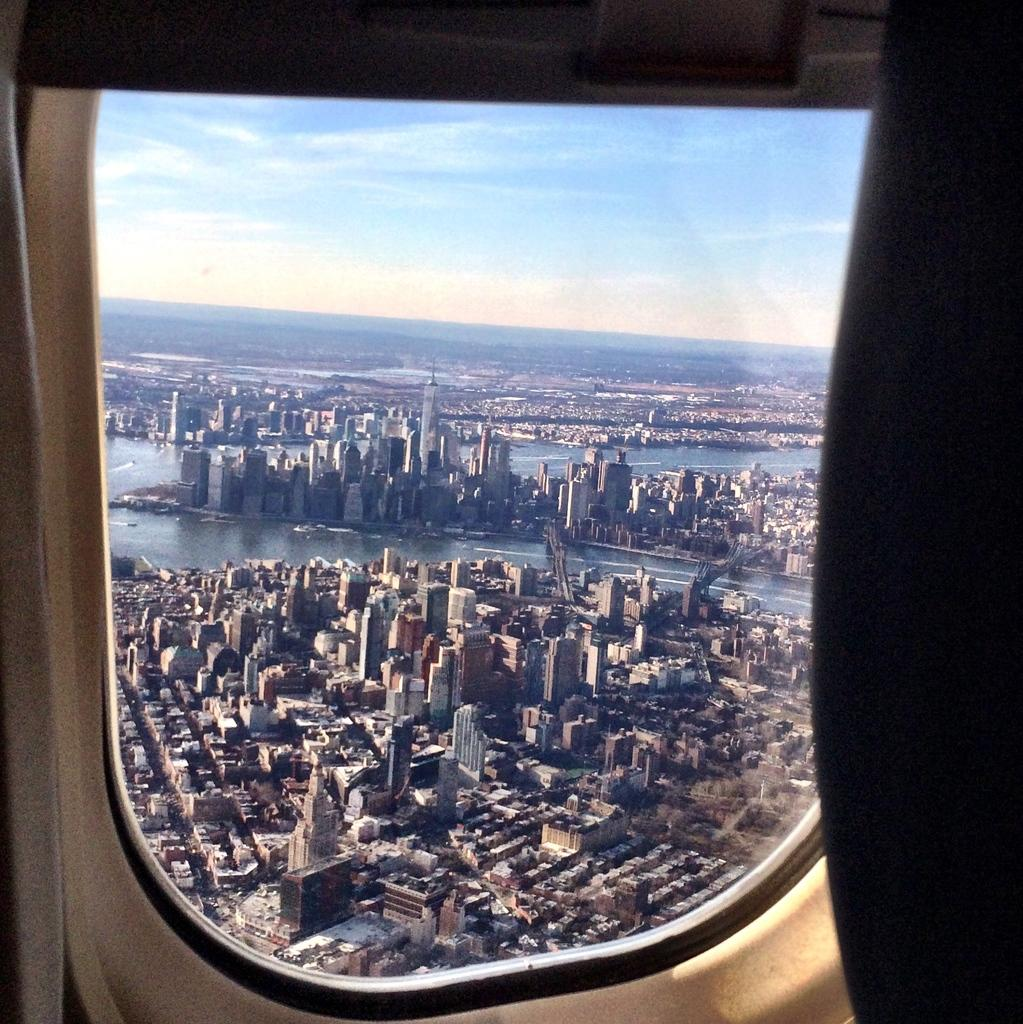What is the main subject of the picture? The main subject of the picture is a window of an airplane. What can be seen in the background of the image? In the background, there are buildings, water, and the sky visible. Can you tell me how many plants are visible through the airplane window? There is no plant visible through the airplane window in the image. What direction is the airplane being pushed in the image? There is no indication of the airplane being pushed in the image. 